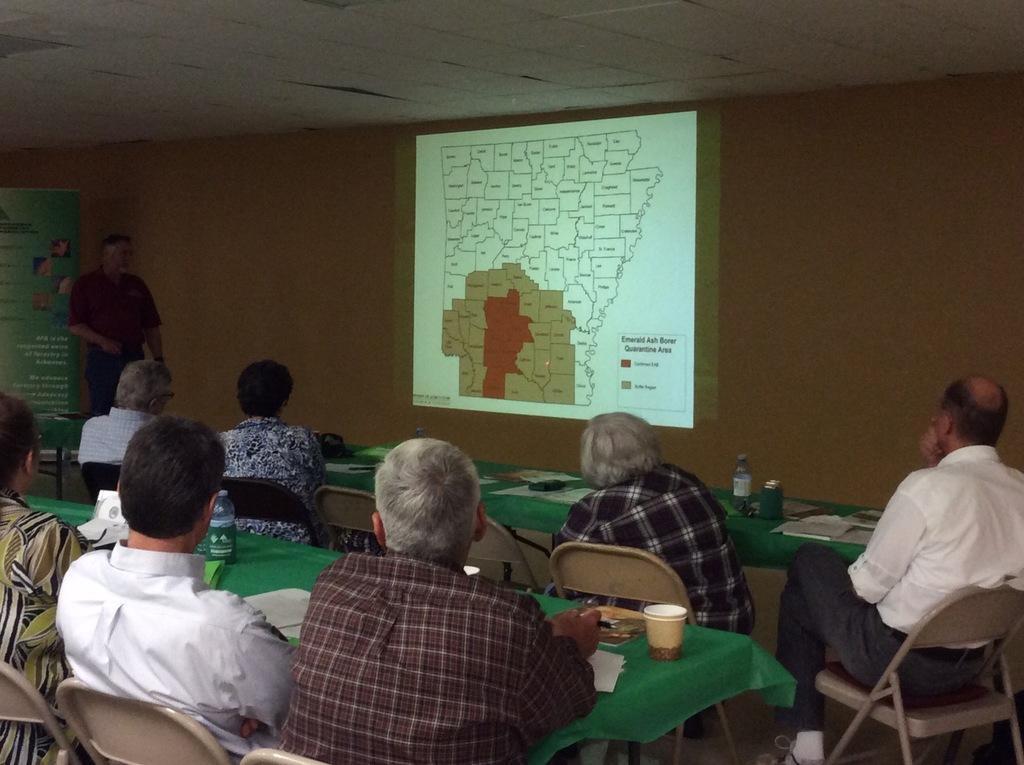How would you summarize this image in a sentence or two? In this image, there are some tables which are covered by a green color clothes, on that tables there are some bottles and there is a glass which is in white color, there are some people sitting on the chairs around the tables, in the background there is a white color wall and there is a power point projection on the wall which is in white color. 